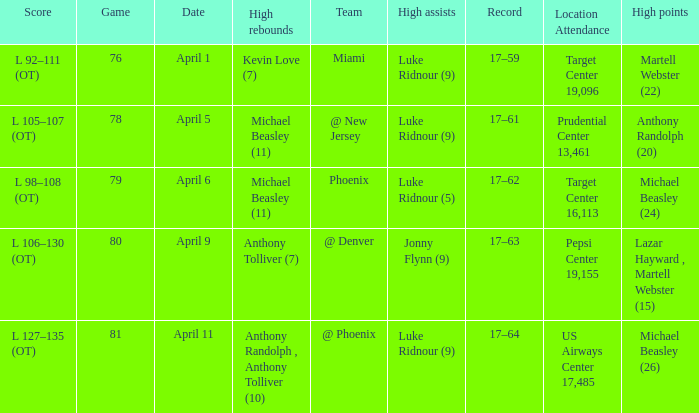How many different results for high rebounds were there for game number 76? 1.0. 